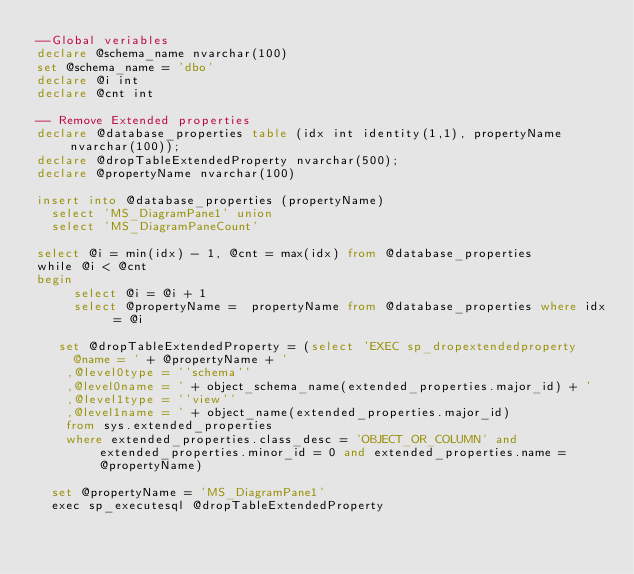<code> <loc_0><loc_0><loc_500><loc_500><_SQL_>--Global veriables
declare @schema_name nvarchar(100)
set @schema_name = 'dbo'
declare @i int
declare @cnt int

-- Remove Extended properties
declare @database_properties table (idx int identity(1,1), propertyName nvarchar(100));
declare @dropTableExtendedProperty nvarchar(500);
declare @propertyName nvarchar(100)

insert into @database_properties (propertyName)
	select 'MS_DiagramPane1' union
	select 'MS_DiagramPaneCount'

select @i = min(idx) - 1, @cnt = max(idx) from @database_properties
while @i < @cnt
begin
     select @i = @i + 1
     select @propertyName =  propertyName from @database_properties where idx = @i

	 set @dropTableExtendedProperty = (select 'EXEC sp_dropextendedproperty
     @name = ' + @propertyName + ' 
    ,@level0type = ''schema''
    ,@level0name = ' + object_schema_name(extended_properties.major_id) + '
    ,@level1type = ''view''
    ,@level1name = ' + object_name(extended_properties.major_id)
    from sys.extended_properties
    where extended_properties.class_desc = 'OBJECT_OR_COLUMN' and extended_properties.minor_id = 0 and extended_properties.name = @propertyName)

	set @propertyName = 'MS_DiagramPane1'
	exec sp_executesql @dropTableExtendedProperty</code> 